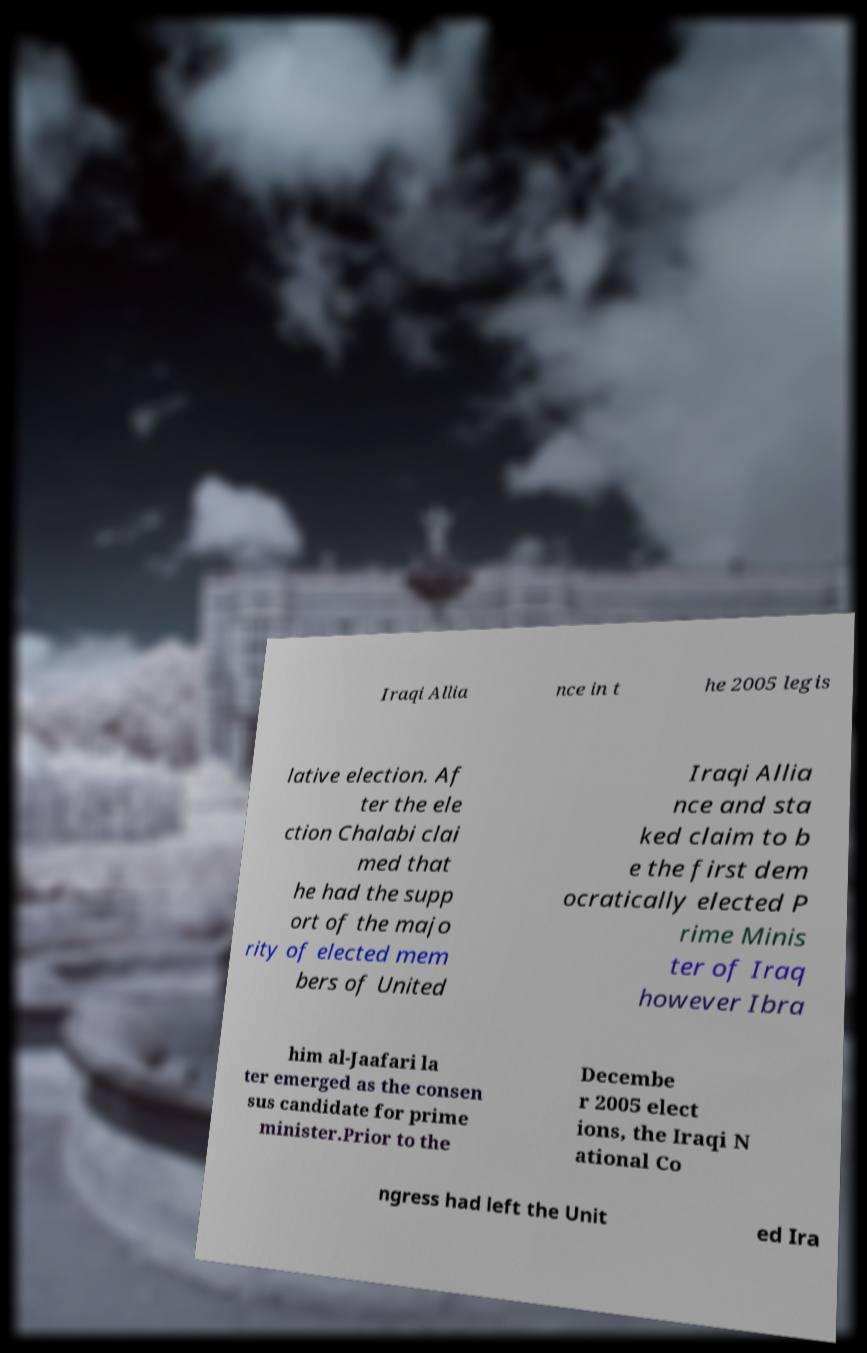Can you accurately transcribe the text from the provided image for me? Iraqi Allia nce in t he 2005 legis lative election. Af ter the ele ction Chalabi clai med that he had the supp ort of the majo rity of elected mem bers of United Iraqi Allia nce and sta ked claim to b e the first dem ocratically elected P rime Minis ter of Iraq however Ibra him al-Jaafari la ter emerged as the consen sus candidate for prime minister.Prior to the Decembe r 2005 elect ions, the Iraqi N ational Co ngress had left the Unit ed Ira 